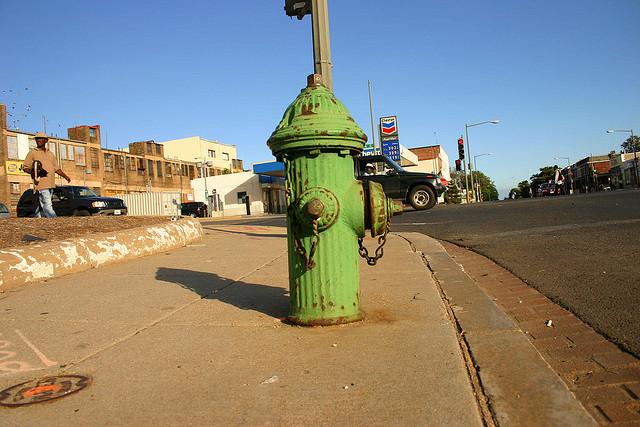What gas station is in the back?
Concise answer only. Chevron. What is the color of the hydrant?
Concise answer only. Green. Is the gas expensive?
Answer briefly. Yes. 